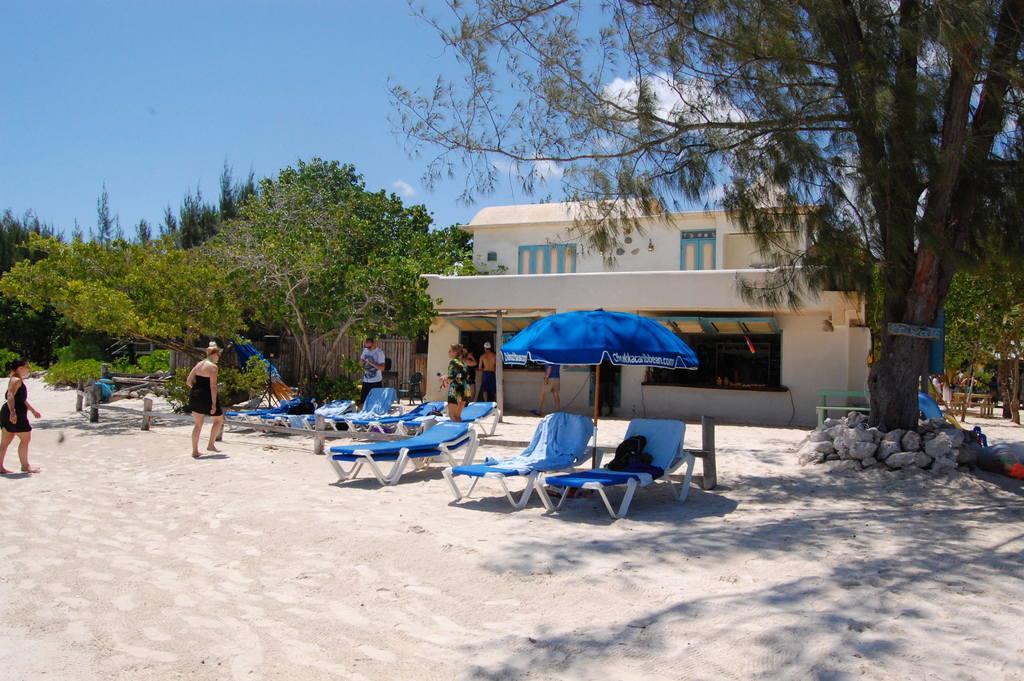Can you describe this image briefly? In this image we can see few people. There are chairs and umbrella. Also there are trees. Also there are stones. In the back there is a building with windows. In the background there is sky with clouds. 